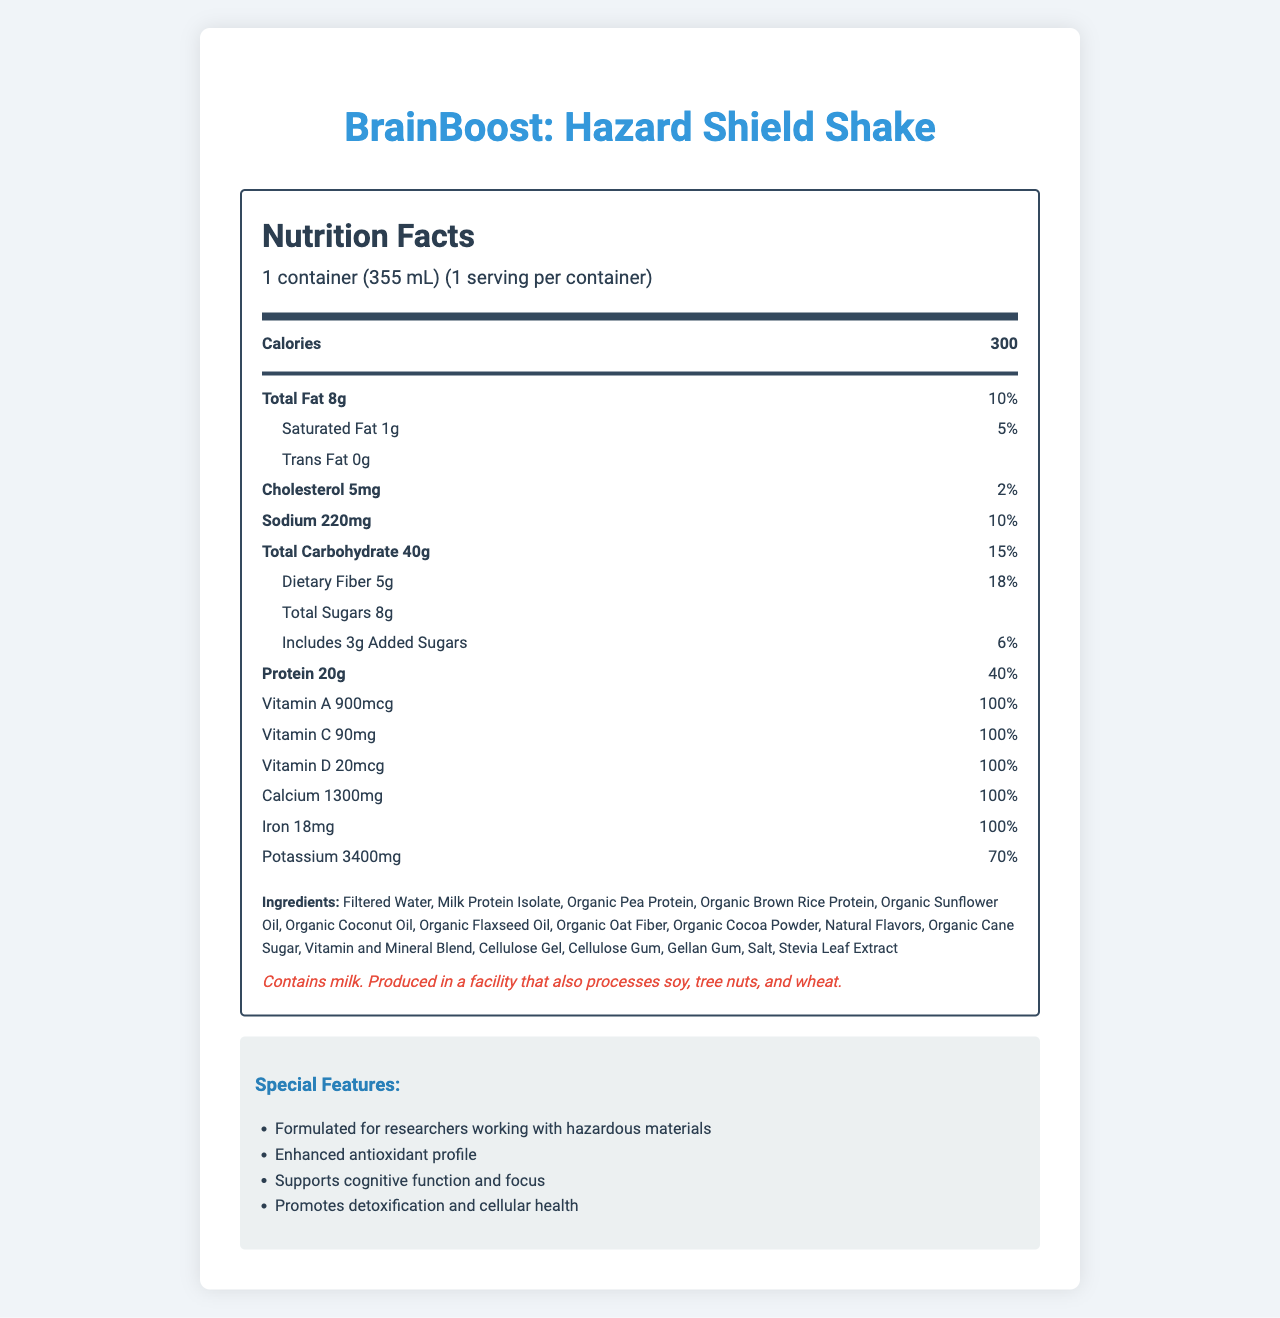What is the serving size of the BrainBoost: Hazard Shield Shake? The serving size is mentioned in the document as "1 container (355 mL)".
Answer: 1 container (355 mL) How many calories are in one serving of the BrainBoost: Hazard Shield Shake? The document lists that there are 300 calories per serving.
Answer: 300 What is the amount of protein in the BrainBoost: Hazard Shield Shake? The document states that there is 20g of protein per serving and it makes up 40% of the daily value.
Answer: 20g Which vitamin is provided at 100% daily value in the BrainBoost: Hazard Shield Shake? A. Vitamin A B. Vitamin B12 C. Vitamin D D. All of the above The document lists several vitamins (A, B12, D, and others) at 100% daily value.
Answer: D What type of oils are included in the ingredients of the BrainBoost: Hazard Shield Shake? The ingredient list mentions Organic Sunflower Oil, Organic Coconut Oil, and Organic Flaxseed Oil as part of the composition.
Answer: Organic Sunflower Oil, Organic Coconut Oil, Organic Flaxseed Oil Does the BrainBoost: Hazard Shield Shake contain any trans fat? The nutrition facts section explicitly indicates "Trans Fat 0g".
Answer: No What is the stated purpose of the BrainBoost: Hazard Shield Shake? The special features section mentions that this product is formulated for researchers working with hazardous materials.
Answer: Formulated for researchers working with hazardous materials What is the daily value percentage of potassium in the BrainBoost: Hazard Shield Shake? The document states that the serving provides 70% of the daily value for potassium.
Answer: 70% Which of the following is NOT a special feature of the BrainBoost: Hazard Shield Shake? A. Supports joint health B. Enhanced antioxidant profile C. Supports cognitive function and focus D. Promotes detoxification and cellular health Joint health is not mentioned as a special feature in the document.
Answer: A Is the BrainBoost: Hazard Shield Shake suitable for someone with a milk allergy? The allergen information states that the product contains milk.
Answer: No Describe the main idea of the nutrition facts label for the BrainBoost: Hazard Shield Shake. This explanation captures the document's comprehensive details encompassing the nutritional content, purpose, special features, and ingredient information.
Answer: The BrainBoost: Hazard Shield Shake is a fortified meal replacement shake designed for researchers working with hazardous materials. It provides a balanced amount of macronutrients and is rich in various vitamins and minerals, many of which meet 100% of the daily values. It includes several organic ingredients and specific features aimed at cognitive function, detoxification, and antioxidant support. How much glutathione is present in the BrainBoost: Hazard Shield Shake? The document lists 250mg of glutathione under the nutrition facts.
Answer: 250mg What is the percentage of the daily value of dietary fiber in the BrainBoost: Hazard Shield Shake? The nutrition label indicates that dietary fiber in the shake accounts for 18% of the daily value.
Answer: 18% Does the BrainBoost: Hazard Shield Shake contain any added sugars? The document lists 3g of added sugars, which is 6% of the daily value.
Answer: Yes Can we determine the price of the BrainBoost: Hazard Shield Shake from the document? The document does not provide any information regarding the price of the product.
Answer: Cannot be determined What is the total amount of fat in the BrainBoost: Hazard Shield Shake? The document states that there are 8g of total fat per serving, which accounts for 10% of the daily value.
Answer: 8g 